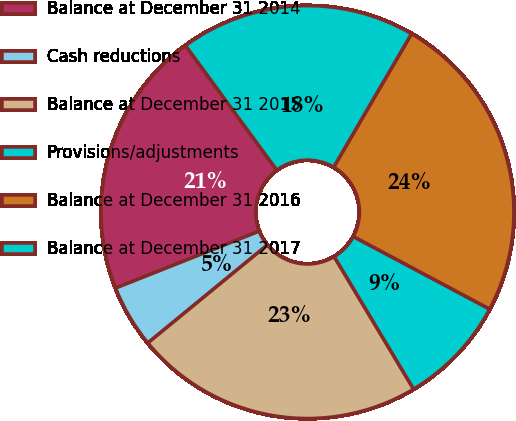Convert chart. <chart><loc_0><loc_0><loc_500><loc_500><pie_chart><fcel>Balance at December 31 2014<fcel>Cash reductions<fcel>Balance at December 31 2015<fcel>Provisions/adjustments<fcel>Balance at December 31 2016<fcel>Balance at December 31 2017<nl><fcel>20.94%<fcel>4.93%<fcel>22.66%<fcel>8.62%<fcel>24.38%<fcel>18.47%<nl></chart> 